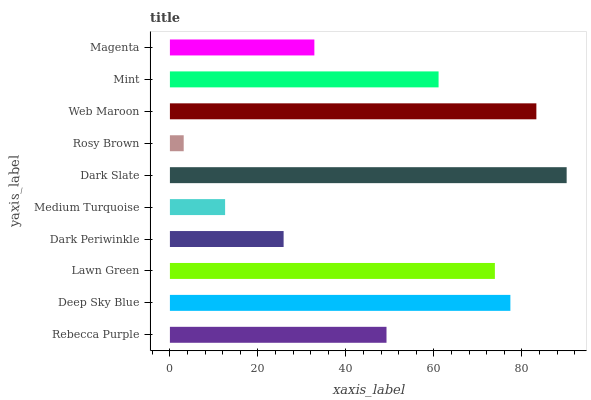Is Rosy Brown the minimum?
Answer yes or no. Yes. Is Dark Slate the maximum?
Answer yes or no. Yes. Is Deep Sky Blue the minimum?
Answer yes or no. No. Is Deep Sky Blue the maximum?
Answer yes or no. No. Is Deep Sky Blue greater than Rebecca Purple?
Answer yes or no. Yes. Is Rebecca Purple less than Deep Sky Blue?
Answer yes or no. Yes. Is Rebecca Purple greater than Deep Sky Blue?
Answer yes or no. No. Is Deep Sky Blue less than Rebecca Purple?
Answer yes or no. No. Is Mint the high median?
Answer yes or no. Yes. Is Rebecca Purple the low median?
Answer yes or no. Yes. Is Rebecca Purple the high median?
Answer yes or no. No. Is Deep Sky Blue the low median?
Answer yes or no. No. 